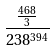Convert formula to latex. <formula><loc_0><loc_0><loc_500><loc_500>\frac { \frac { 4 6 8 } { 3 } } { 2 3 8 ^ { 3 9 4 } }</formula> 